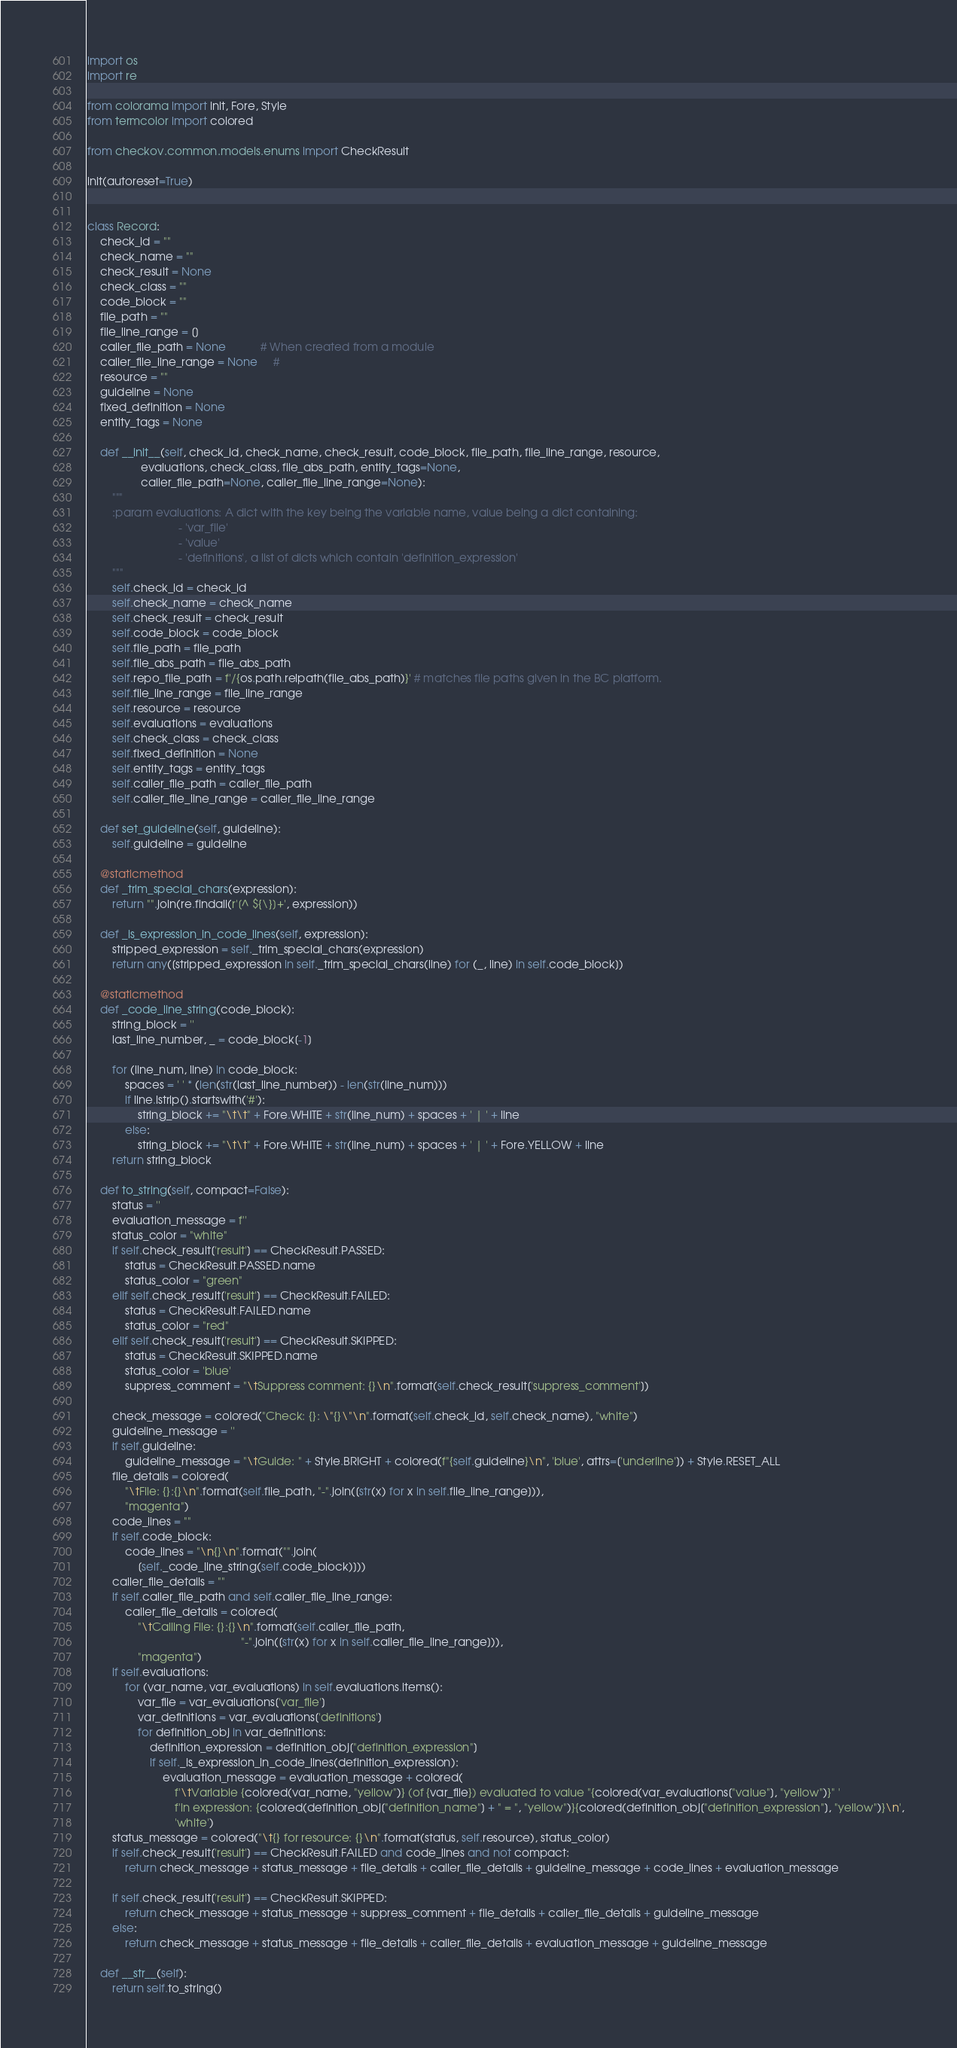Convert code to text. <code><loc_0><loc_0><loc_500><loc_500><_Python_>import os
import re

from colorama import init, Fore, Style
from termcolor import colored

from checkov.common.models.enums import CheckResult

init(autoreset=True)


class Record:
    check_id = ""
    check_name = ""
    check_result = None
    check_class = ""
    code_block = ""
    file_path = ""
    file_line_range = []
    caller_file_path = None           # When created from a module
    caller_file_line_range = None     #
    resource = ""
    guideline = None
    fixed_definition = None
    entity_tags = None

    def __init__(self, check_id, check_name, check_result, code_block, file_path, file_line_range, resource,
                 evaluations, check_class, file_abs_path, entity_tags=None,
                 caller_file_path=None, caller_file_line_range=None):
        """
        :param evaluations: A dict with the key being the variable name, value being a dict containing:
                             - 'var_file'
                             - 'value'
                             - 'definitions', a list of dicts which contain 'definition_expression'
        """
        self.check_id = check_id
        self.check_name = check_name
        self.check_result = check_result
        self.code_block = code_block
        self.file_path = file_path
        self.file_abs_path = file_abs_path
        self.repo_file_path = f'/{os.path.relpath(file_abs_path)}' # matches file paths given in the BC platform.
        self.file_line_range = file_line_range
        self.resource = resource
        self.evaluations = evaluations
        self.check_class = check_class
        self.fixed_definition = None
        self.entity_tags = entity_tags
        self.caller_file_path = caller_file_path
        self.caller_file_line_range = caller_file_line_range

    def set_guideline(self, guideline):
        self.guideline = guideline

    @staticmethod
    def _trim_special_chars(expression):
        return "".join(re.findall(r'[^ ${\}]+', expression))

    def _is_expression_in_code_lines(self, expression):
        stripped_expression = self._trim_special_chars(expression)
        return any([stripped_expression in self._trim_special_chars(line) for (_, line) in self.code_block])

    @staticmethod
    def _code_line_string(code_block):
        string_block = ''
        last_line_number, _ = code_block[-1]

        for (line_num, line) in code_block:
            spaces = ' ' * (len(str(last_line_number)) - len(str(line_num)))
            if line.lstrip().startswith('#'):
                string_block += "\t\t" + Fore.WHITE + str(line_num) + spaces + ' | ' + line
            else:
                string_block += "\t\t" + Fore.WHITE + str(line_num) + spaces + ' | ' + Fore.YELLOW + line
        return string_block

    def to_string(self, compact=False):
        status = ''
        evaluation_message = f''
        status_color = "white"
        if self.check_result['result'] == CheckResult.PASSED:
            status = CheckResult.PASSED.name
            status_color = "green"
        elif self.check_result['result'] == CheckResult.FAILED:
            status = CheckResult.FAILED.name
            status_color = "red"
        elif self.check_result['result'] == CheckResult.SKIPPED:
            status = CheckResult.SKIPPED.name
            status_color = 'blue'
            suppress_comment = "\tSuppress comment: {}\n".format(self.check_result['suppress_comment'])

        check_message = colored("Check: {}: \"{}\"\n".format(self.check_id, self.check_name), "white")
        guideline_message = ''
        if self.guideline:
            guideline_message = "\tGuide: " + Style.BRIGHT + colored(f"{self.guideline}\n", 'blue', attrs=['underline']) + Style.RESET_ALL
        file_details = colored(
            "\tFile: {}:{}\n".format(self.file_path, "-".join([str(x) for x in self.file_line_range])),
            "magenta")
        code_lines = ""
        if self.code_block:
            code_lines = "\n{}\n".format("".join(
                [self._code_line_string(self.code_block)]))
        caller_file_details = ""
        if self.caller_file_path and self.caller_file_line_range:
            caller_file_details = colored(
                "\tCalling File: {}:{}\n".format(self.caller_file_path,
                                                 "-".join([str(x) for x in self.caller_file_line_range])),
                "magenta")
        if self.evaluations:
            for (var_name, var_evaluations) in self.evaluations.items():
                var_file = var_evaluations['var_file']
                var_definitions = var_evaluations['definitions']
                for definition_obj in var_definitions:
                    definition_expression = definition_obj["definition_expression"]
                    if self._is_expression_in_code_lines(definition_expression):
                        evaluation_message = evaluation_message + colored(
                            f'\tVariable {colored(var_name, "yellow")} (of {var_file}) evaluated to value "{colored(var_evaluations["value"], "yellow")}" '
                            f'in expression: {colored(definition_obj["definition_name"] + " = ", "yellow")}{colored(definition_obj["definition_expression"], "yellow")}\n',
                            'white')
        status_message = colored("\t{} for resource: {}\n".format(status, self.resource), status_color)
        if self.check_result['result'] == CheckResult.FAILED and code_lines and not compact:
            return check_message + status_message + file_details + caller_file_details + guideline_message + code_lines + evaluation_message

        if self.check_result['result'] == CheckResult.SKIPPED:
            return check_message + status_message + suppress_comment + file_details + caller_file_details + guideline_message
        else:
            return check_message + status_message + file_details + caller_file_details + evaluation_message + guideline_message

    def __str__(self):
        return self.to_string()
</code> 